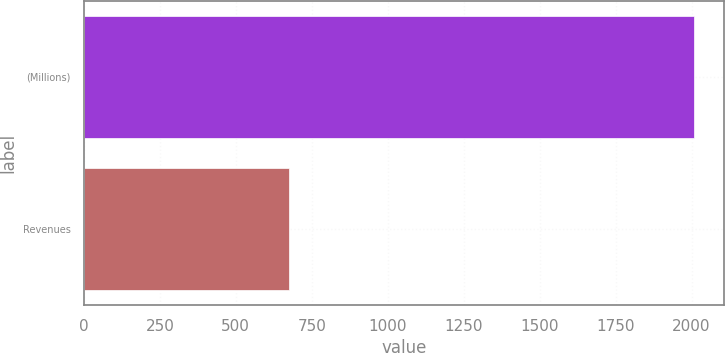Convert chart. <chart><loc_0><loc_0><loc_500><loc_500><bar_chart><fcel>(Millions)<fcel>Revenues<nl><fcel>2007<fcel>674<nl></chart> 